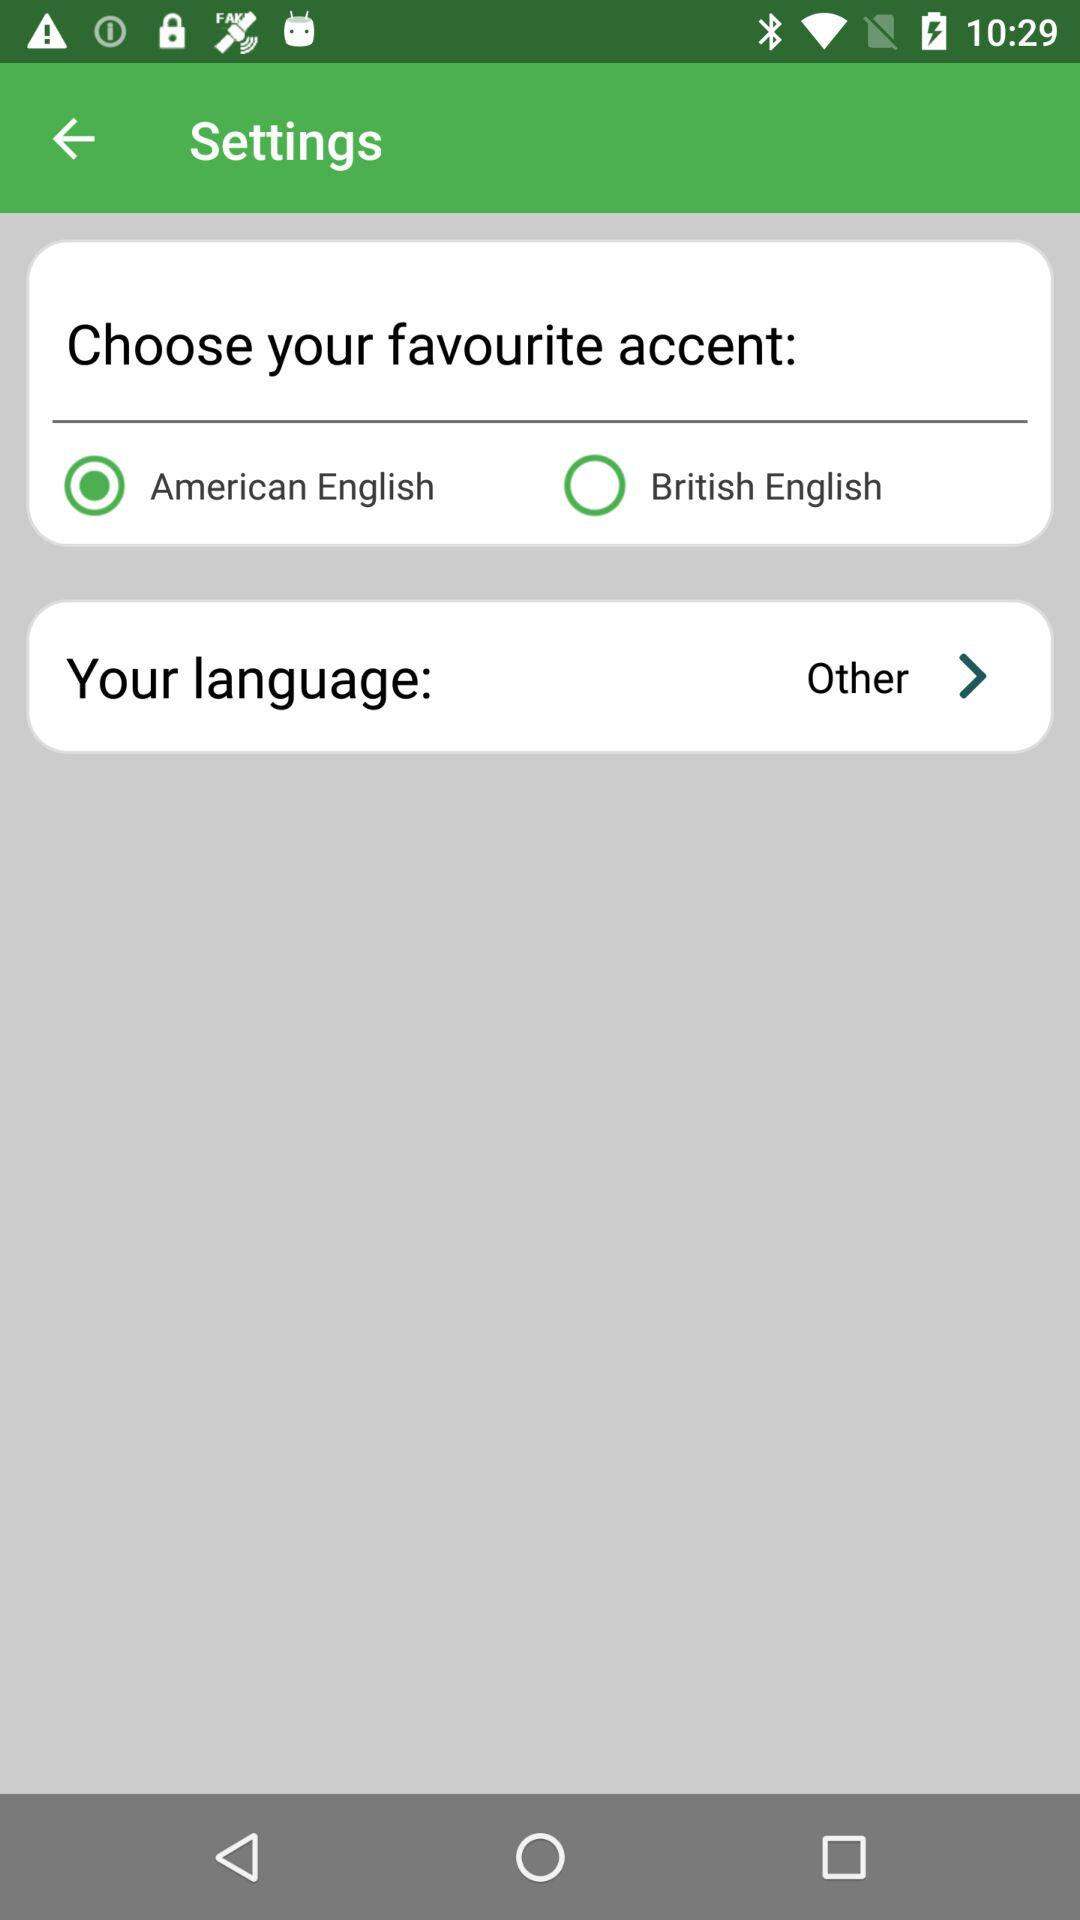How many accent options are available?
Answer the question using a single word or phrase. 2 